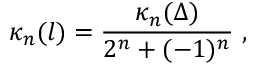Convert formula to latex. <formula><loc_0><loc_0><loc_500><loc_500>\kappa _ { n } ( l ) = \frac { \kappa _ { n } ( \Delta ) } { 2 ^ { n } + ( - 1 ) ^ { n } } \ ,</formula> 